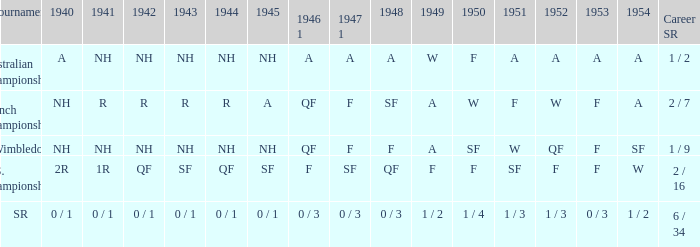What is the tournament that had a result of A in 1954 and NH in 1942? Australian Championships. 